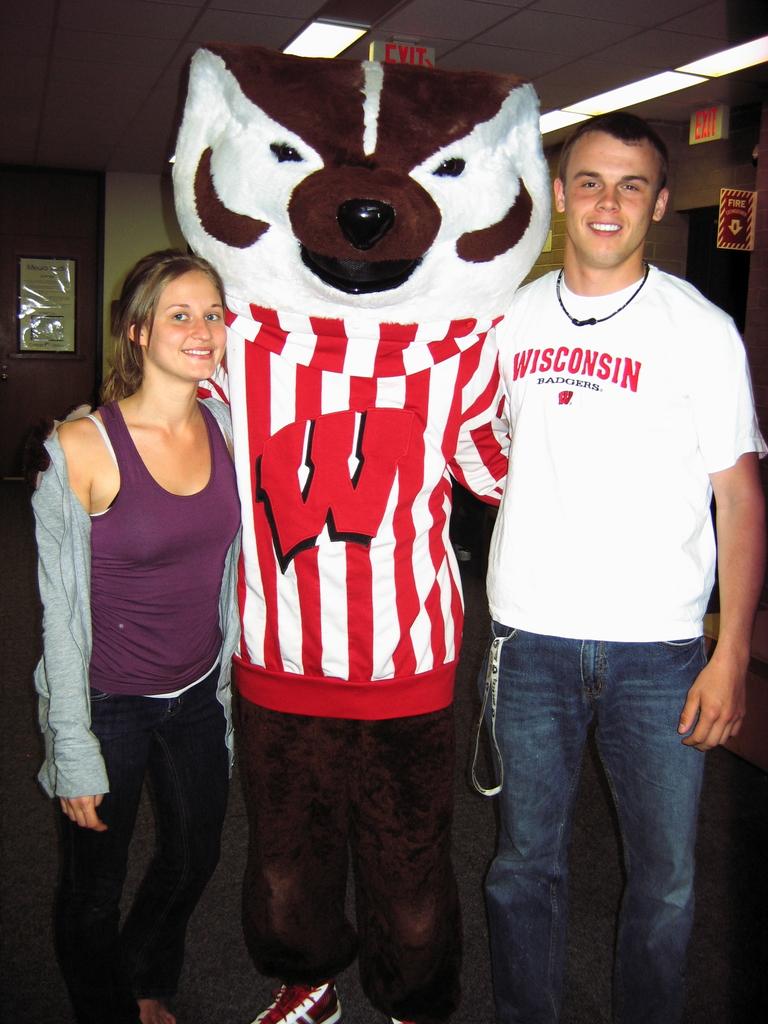What state is the college in?
Provide a short and direct response. Wisconsin. 